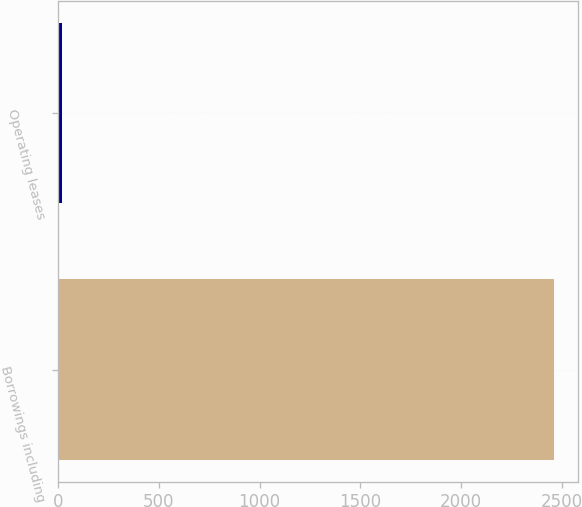Convert chart to OTSL. <chart><loc_0><loc_0><loc_500><loc_500><bar_chart><fcel>Borrowings including<fcel>Operating leases<nl><fcel>2459.6<fcel>19.5<nl></chart> 